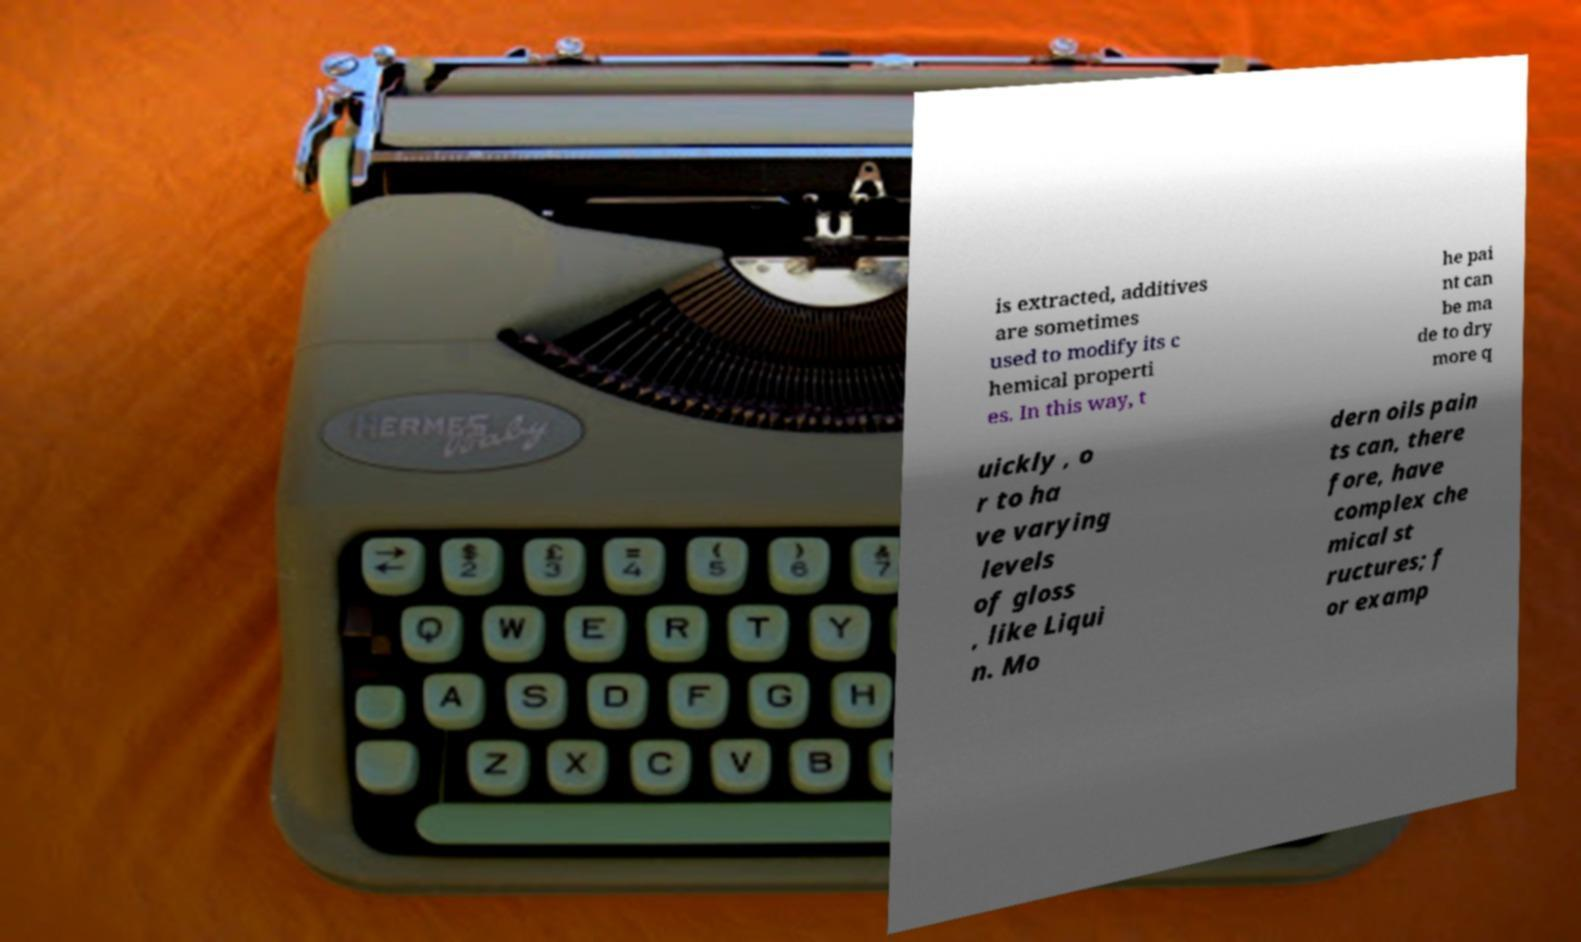Please read and relay the text visible in this image. What does it say? is extracted, additives are sometimes used to modify its c hemical properti es. In this way, t he pai nt can be ma de to dry more q uickly , o r to ha ve varying levels of gloss , like Liqui n. Mo dern oils pain ts can, there fore, have complex che mical st ructures; f or examp 